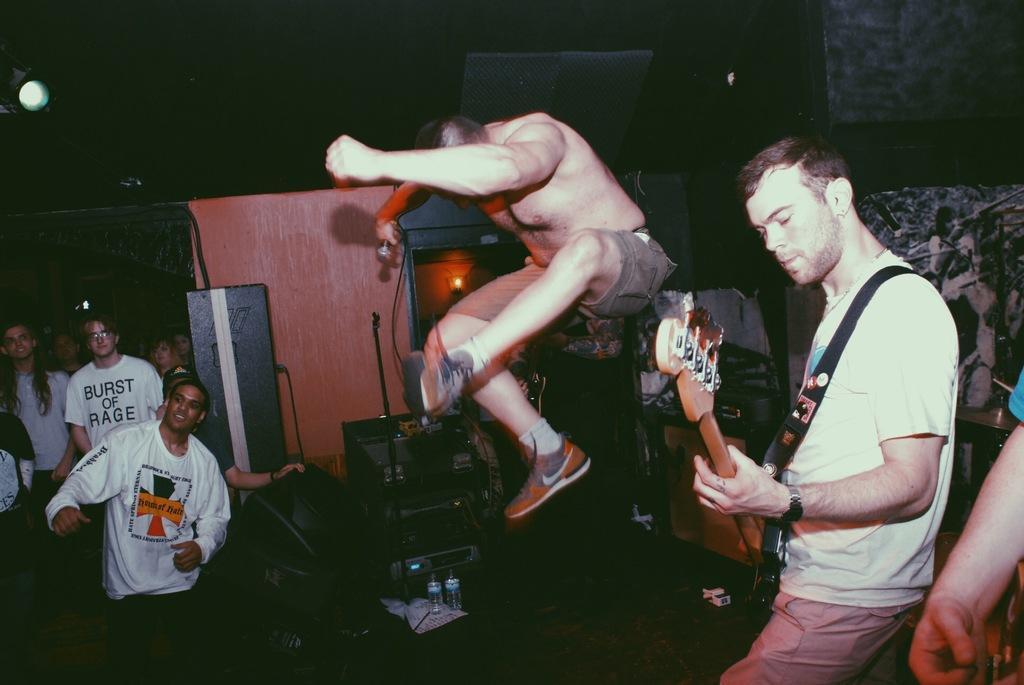Can you describe this image briefly? In this image i can see few persons, the person on the right corner is holding a guitar in his hand and the person in the middle is holding a microphone, and to the left corner i can see few people standing. In the background i can see few photos and some musical system. 